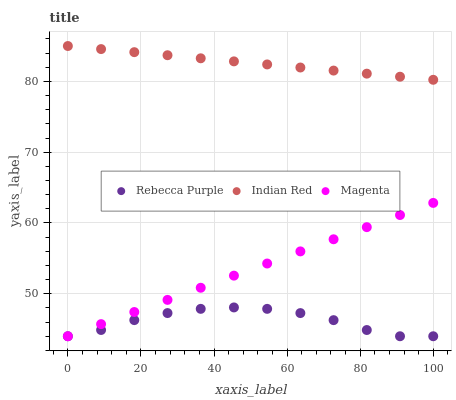Does Rebecca Purple have the minimum area under the curve?
Answer yes or no. Yes. Does Indian Red have the maximum area under the curve?
Answer yes or no. Yes. Does Indian Red have the minimum area under the curve?
Answer yes or no. No. Does Rebecca Purple have the maximum area under the curve?
Answer yes or no. No. Is Indian Red the smoothest?
Answer yes or no. Yes. Is Rebecca Purple the roughest?
Answer yes or no. Yes. Is Rebecca Purple the smoothest?
Answer yes or no. No. Is Indian Red the roughest?
Answer yes or no. No. Does Magenta have the lowest value?
Answer yes or no. Yes. Does Indian Red have the lowest value?
Answer yes or no. No. Does Indian Red have the highest value?
Answer yes or no. Yes. Does Rebecca Purple have the highest value?
Answer yes or no. No. Is Rebecca Purple less than Indian Red?
Answer yes or no. Yes. Is Indian Red greater than Magenta?
Answer yes or no. Yes. Does Rebecca Purple intersect Magenta?
Answer yes or no. Yes. Is Rebecca Purple less than Magenta?
Answer yes or no. No. Is Rebecca Purple greater than Magenta?
Answer yes or no. No. Does Rebecca Purple intersect Indian Red?
Answer yes or no. No. 